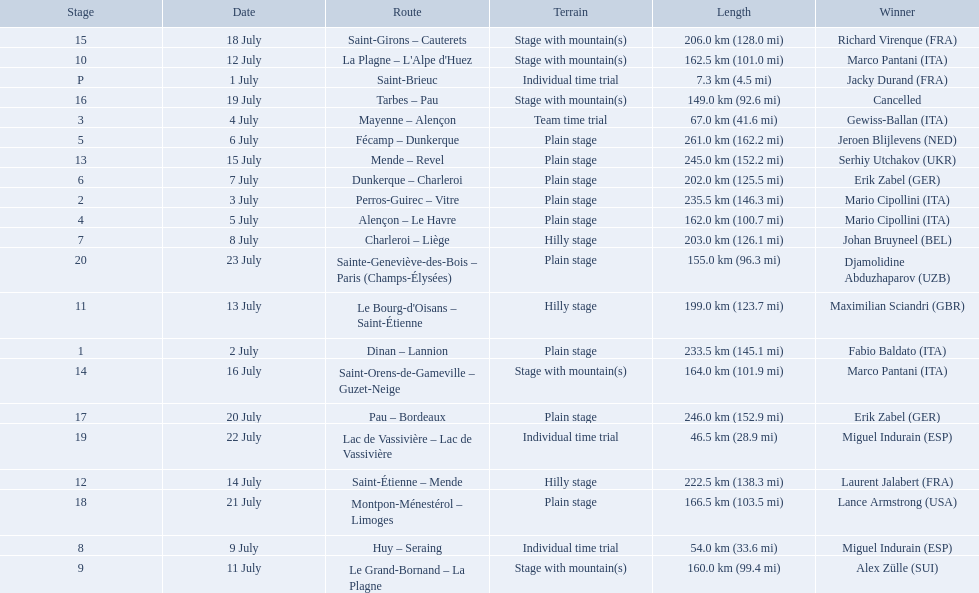What are the dates? 1 July, 2 July, 3 July, 4 July, 5 July, 6 July, 7 July, 8 July, 9 July, 11 July, 12 July, 13 July, 14 July, 15 July, 16 July, 18 July, 19 July, 20 July, 21 July, 22 July, 23 July. What is the length on 8 july? 203.0 km (126.1 mi). 